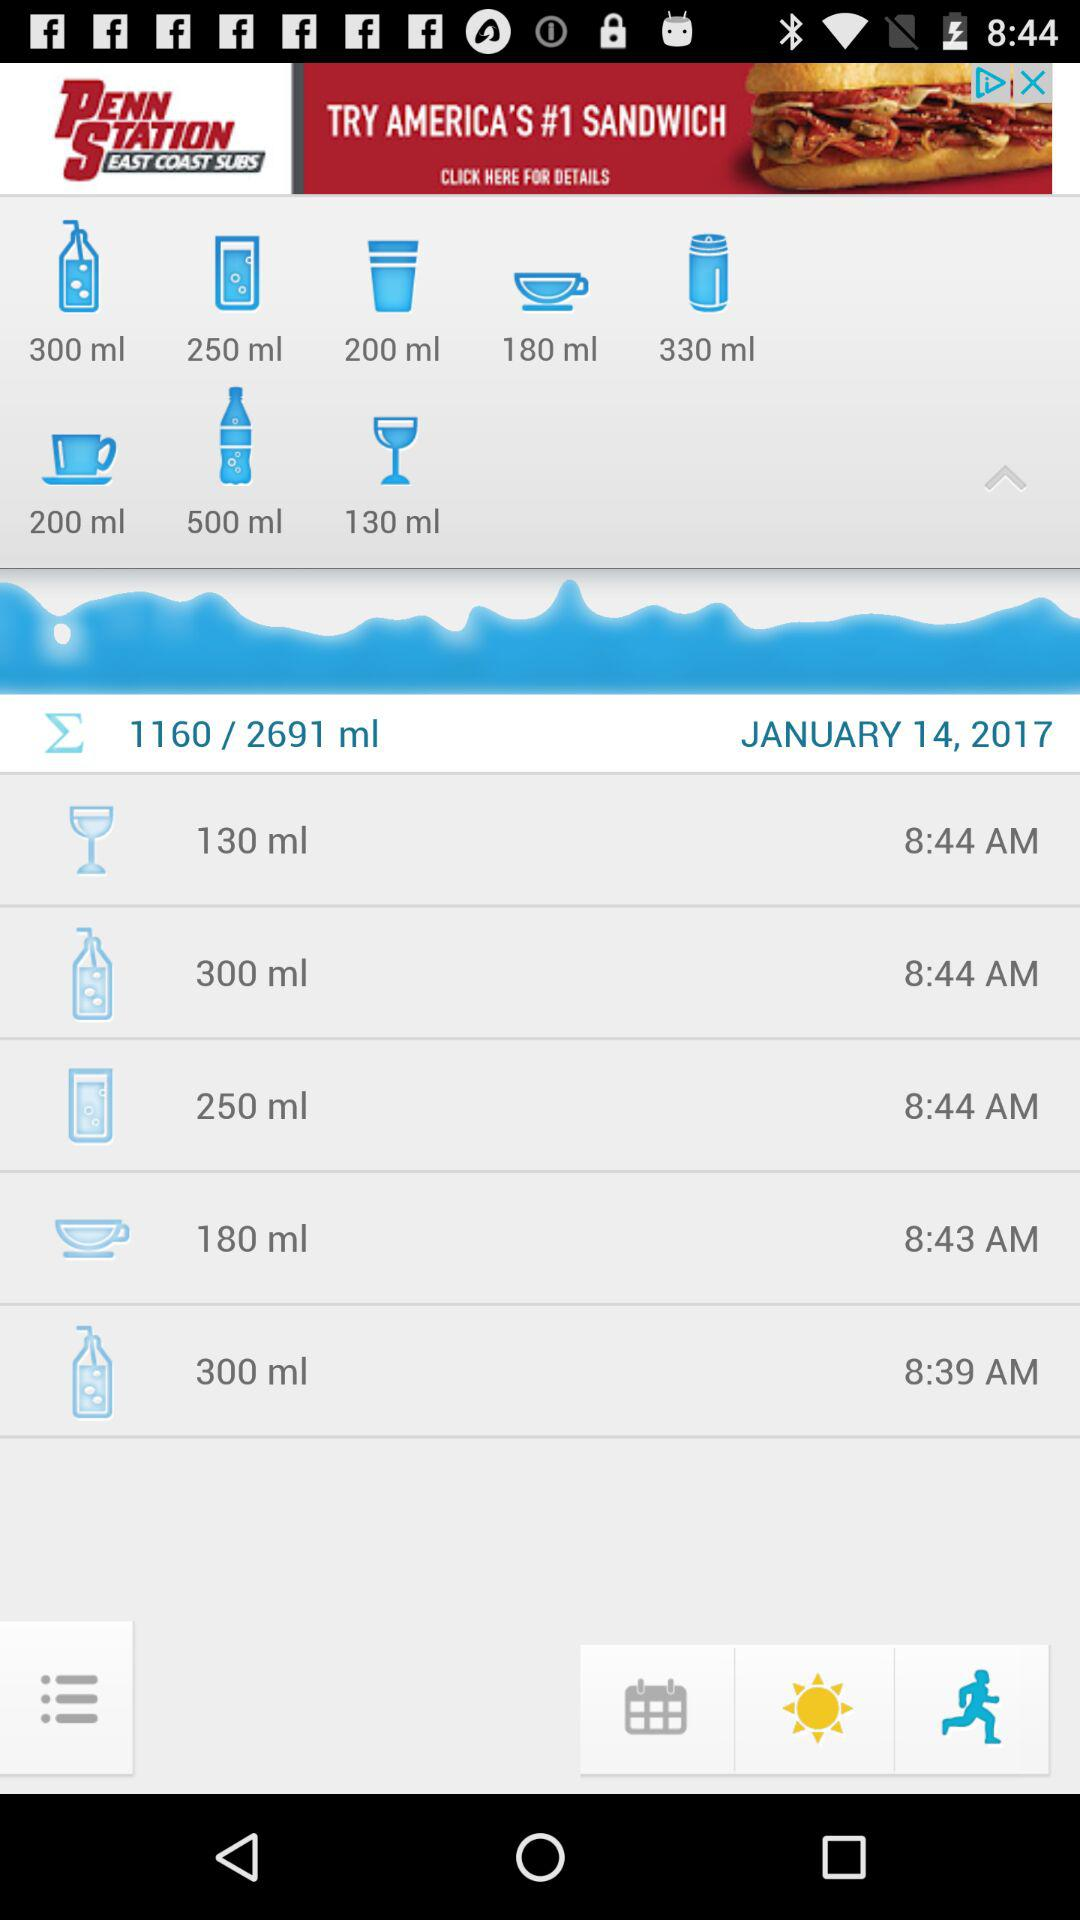What is the time for 180 ml? The time is 8:43 AM. 